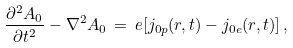<formula> <loc_0><loc_0><loc_500><loc_500>\frac { \partial ^ { 2 } A _ { 0 } } { \partial t ^ { 2 } } - \nabla ^ { 2 } A _ { 0 } \, = \, e [ j _ { 0 p } ( { r } , t ) - j _ { 0 e } ( { r } , t ) ] \, ,</formula> 